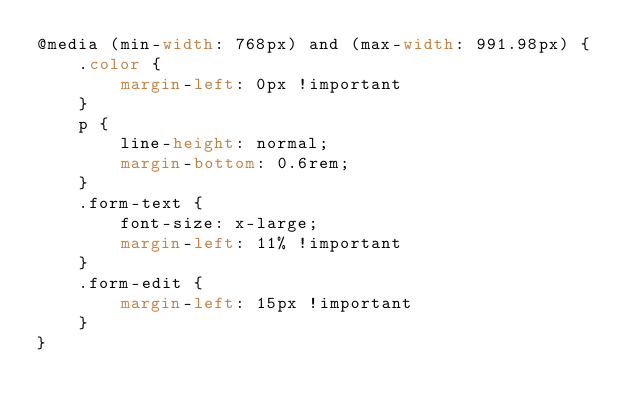Convert code to text. <code><loc_0><loc_0><loc_500><loc_500><_CSS_>@media (min-width: 768px) and (max-width: 991.98px) {
    .color {
        margin-left: 0px !important
    }
    p {
        line-height: normal;
        margin-bottom: 0.6rem;
    }
    .form-text {
        font-size: x-large;
        margin-left: 11% !important
    }
    .form-edit {
        margin-left: 15px !important
    }
}</code> 